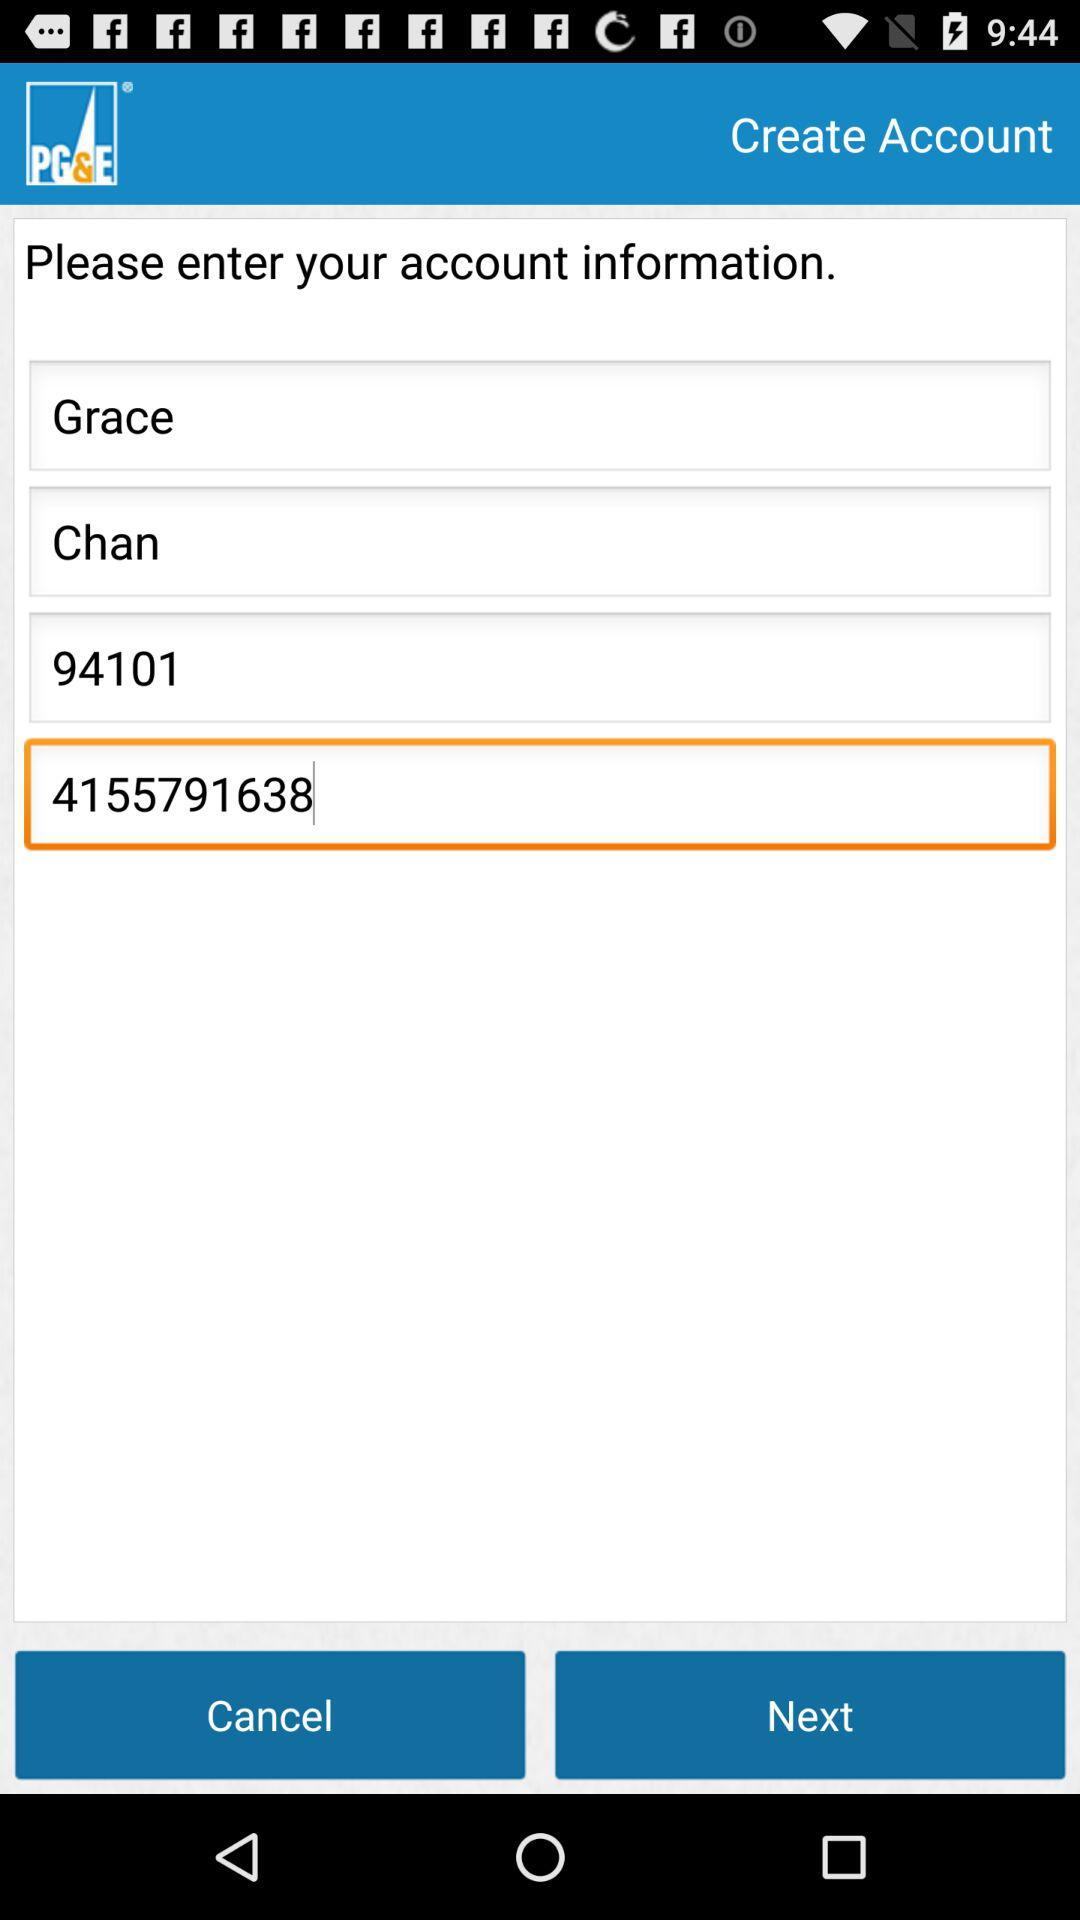How tall is Grace Chan?
When the provided information is insufficient, respond with <no answer>. <no answer> 